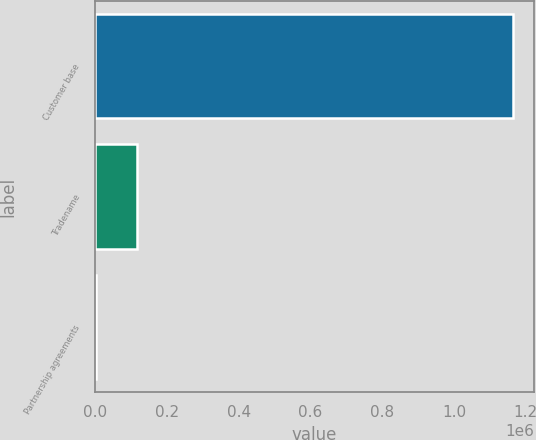Convert chart. <chart><loc_0><loc_0><loc_500><loc_500><bar_chart><fcel>Customer base<fcel>Tradename<fcel>Partnership agreements<nl><fcel>1.16481e+06<fcel>117343<fcel>958<nl></chart> 